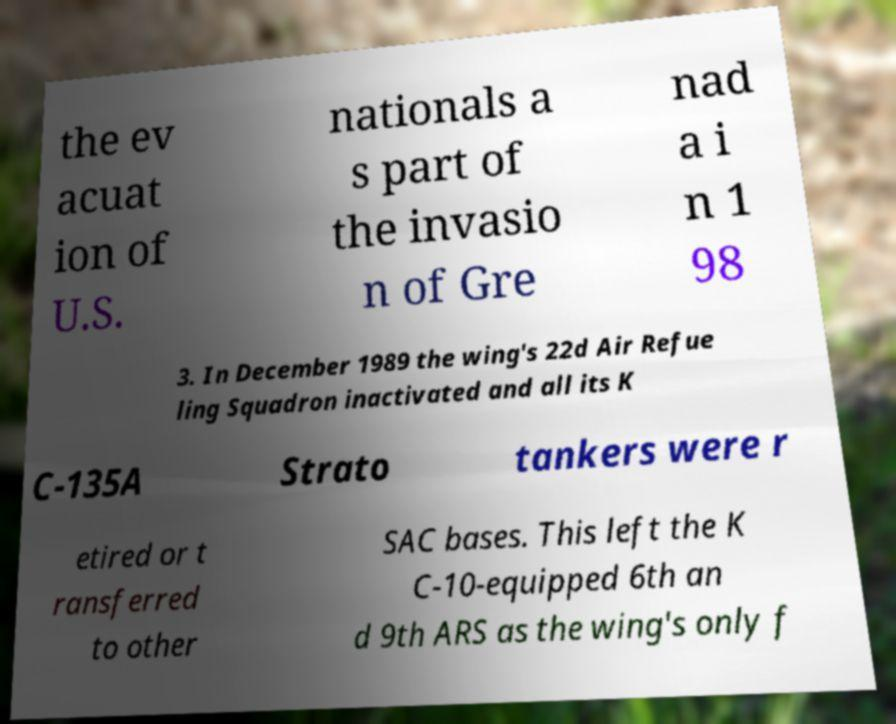Could you extract and type out the text from this image? the ev acuat ion of U.S. nationals a s part of the invasio n of Gre nad a i n 1 98 3. In December 1989 the wing's 22d Air Refue ling Squadron inactivated and all its K C-135A Strato tankers were r etired or t ransferred to other SAC bases. This left the K C-10-equipped 6th an d 9th ARS as the wing's only f 